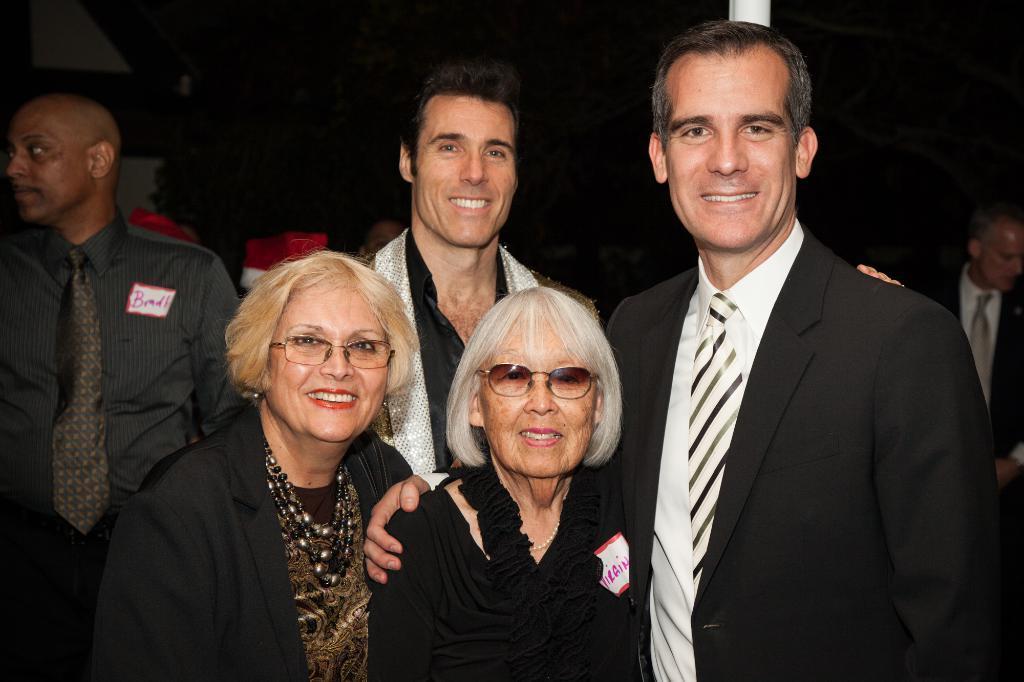Could you give a brief overview of what you see in this image? There are two men and two women standing and smiling. On the left side of the image, I can see another person standing. This looks like an object. On the right side of the image, here is the man standing. The background looks dark. 